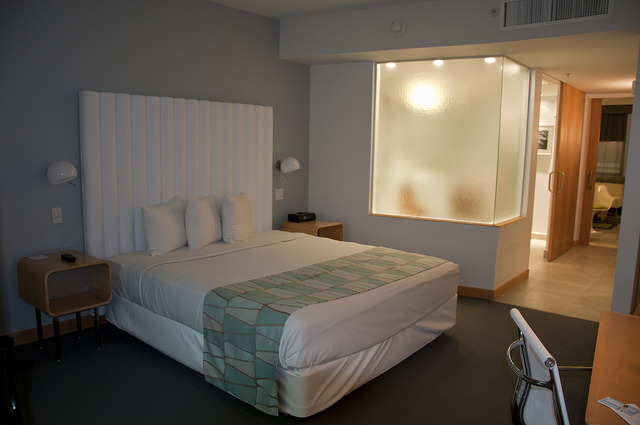How many doors in this closet? Based on the visible design, it appears there is one large sliding door for the closet. It's possible there could be more on the other side, not visible in this image. 